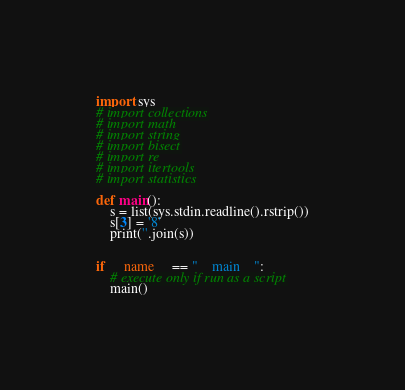<code> <loc_0><loc_0><loc_500><loc_500><_Python_>import sys
# import collections
# import math
# import string
# import bisect
# import re
# import itertools
# import statistics

def main():
    s = list(sys.stdin.readline().rstrip())
    s[3] = '8'
    print(''.join(s))


if __name__ == "__main__":
    # execute only if run as a script
    main()
</code> 